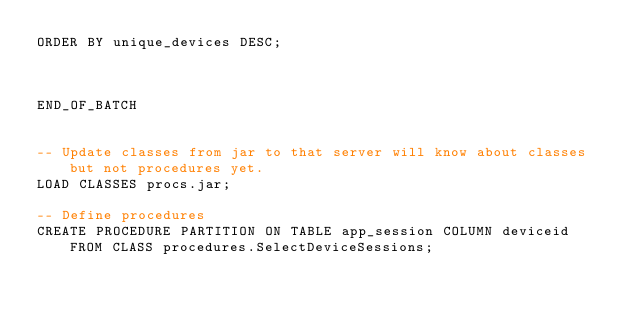Convert code to text. <code><loc_0><loc_0><loc_500><loc_500><_SQL_>ORDER BY unique_devices DESC;



END_OF_BATCH


-- Update classes from jar to that server will know about classes but not procedures yet.
LOAD CLASSES procs.jar;

-- Define procedures
CREATE PROCEDURE PARTITION ON TABLE app_session COLUMN deviceid FROM CLASS procedures.SelectDeviceSessions;

</code> 